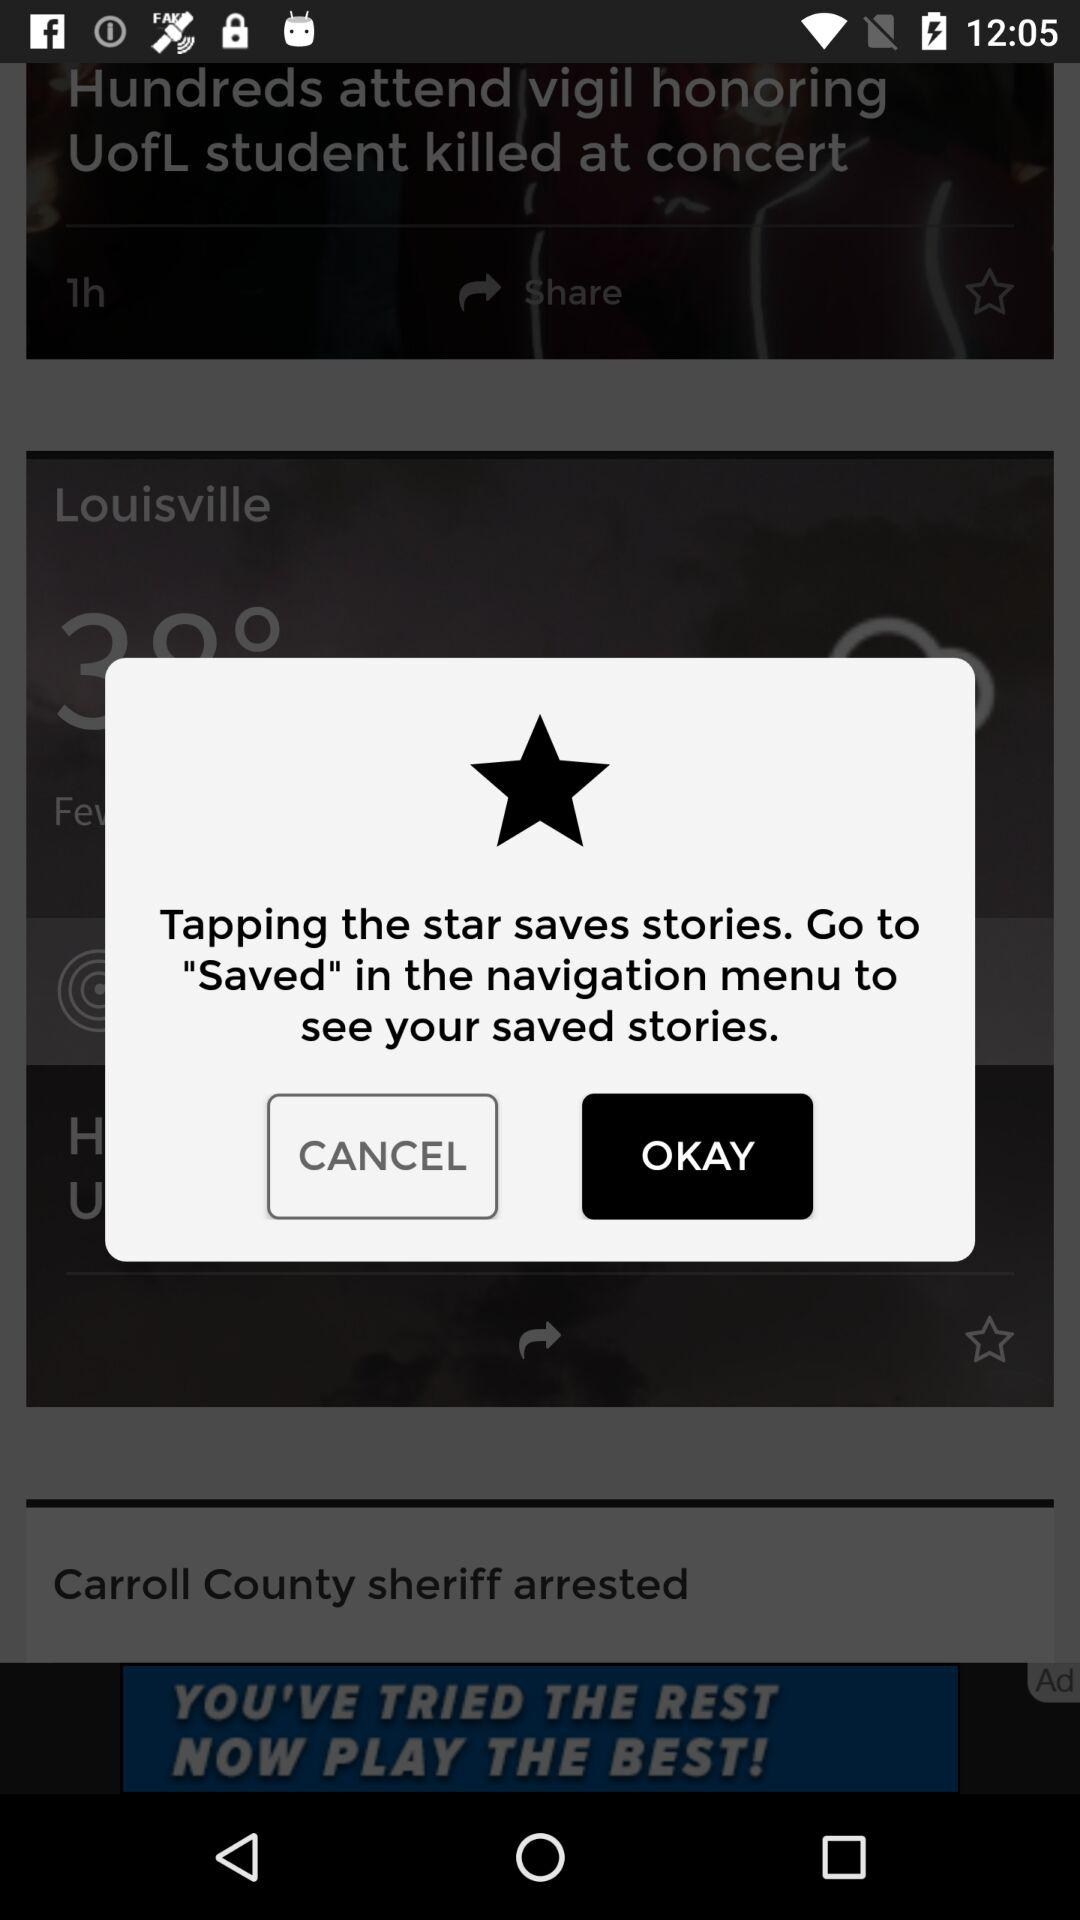How can we see the save stories? The saved stories can be seen by "Tapping the star saves stories. Go to "Saved" in the navigation menu to see your saved stories". 